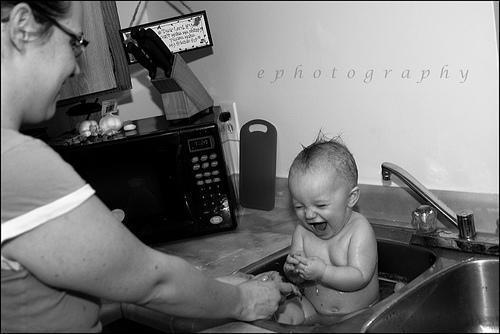How many babies are there in the sink?
Give a very brief answer. 1. How many people are there?
Give a very brief answer. 2. 